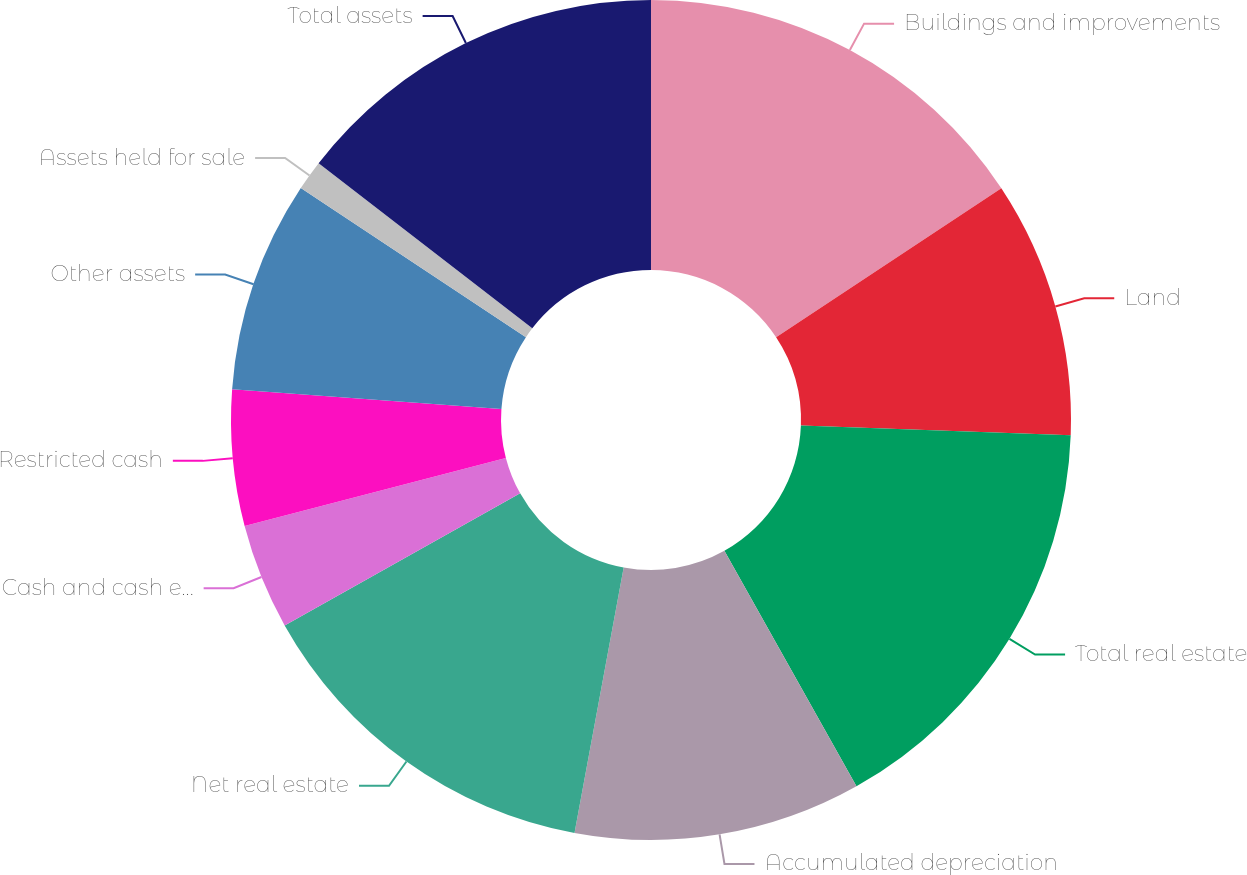Convert chart to OTSL. <chart><loc_0><loc_0><loc_500><loc_500><pie_chart><fcel>Buildings and improvements<fcel>Land<fcel>Total real estate<fcel>Accumulated depreciation<fcel>Net real estate<fcel>Cash and cash equivalents<fcel>Restricted cash<fcel>Other assets<fcel>Assets held for sale<fcel>Total assets<nl><fcel>15.7%<fcel>9.88%<fcel>16.28%<fcel>11.05%<fcel>13.95%<fcel>4.07%<fcel>5.23%<fcel>8.14%<fcel>1.16%<fcel>14.53%<nl></chart> 